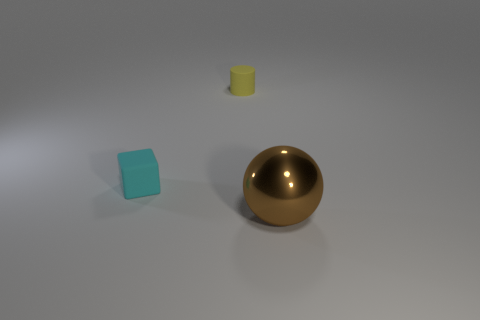There is a thing that is in front of the rubber object in front of the tiny thing behind the tiny cyan rubber block; what shape is it?
Offer a very short reply. Sphere. What number of things are cyan objects or objects on the left side of the big ball?
Ensure brevity in your answer.  2. Does the object on the left side of the yellow cylinder have the same size as the large brown metal ball?
Offer a terse response. No. What is the material of the small thing that is right of the tiny matte cube?
Your answer should be very brief. Rubber. Are there the same number of tiny matte cubes that are right of the rubber cylinder and small yellow rubber objects behind the sphere?
Give a very brief answer. No. Is there any other thing that is the same color as the big object?
Your response must be concise. No. How many shiny things are either purple things or cyan cubes?
Ensure brevity in your answer.  0. Is the small cube the same color as the metallic object?
Provide a short and direct response. No. Are there more brown shiny objects that are right of the big brown sphere than big rubber blocks?
Keep it short and to the point. No. How many other objects are the same material as the tiny cyan block?
Your answer should be very brief. 1. 